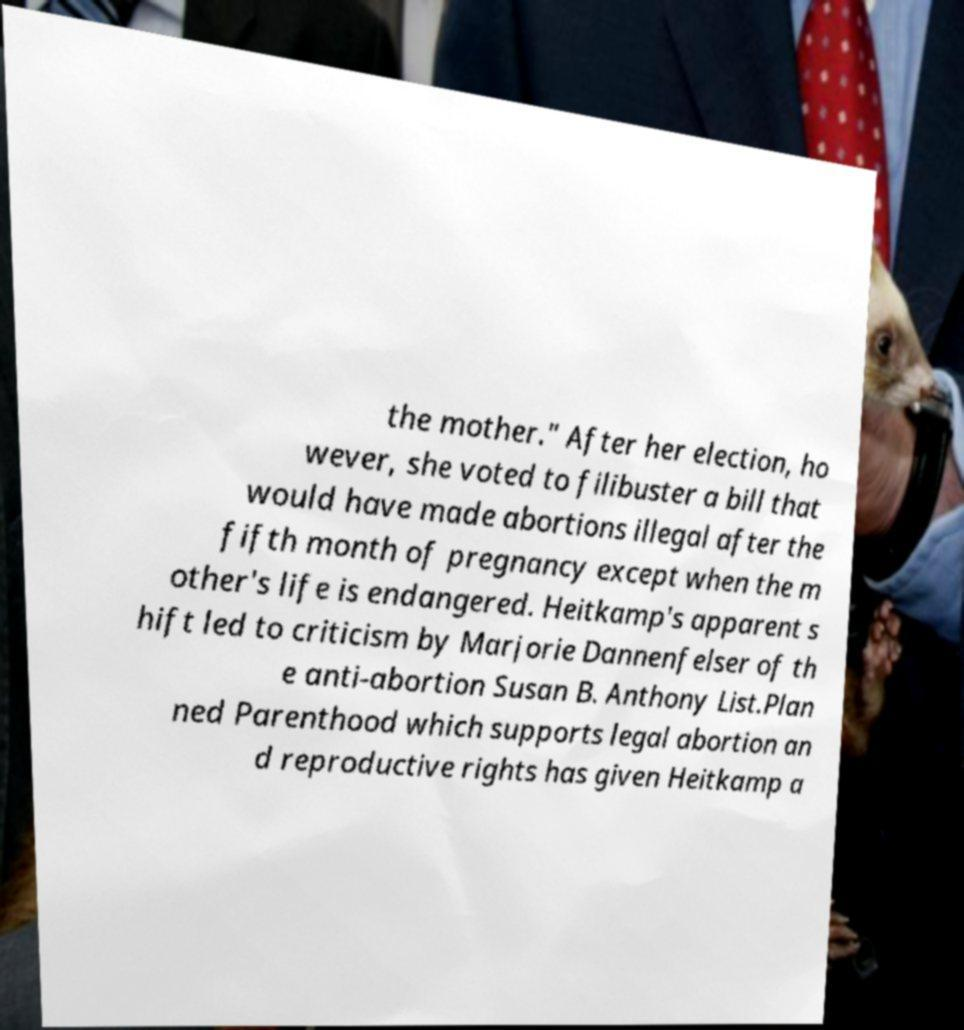Could you extract and type out the text from this image? the mother." After her election, ho wever, she voted to filibuster a bill that would have made abortions illegal after the fifth month of pregnancy except when the m other's life is endangered. Heitkamp's apparent s hift led to criticism by Marjorie Dannenfelser of th e anti-abortion Susan B. Anthony List.Plan ned Parenthood which supports legal abortion an d reproductive rights has given Heitkamp a 